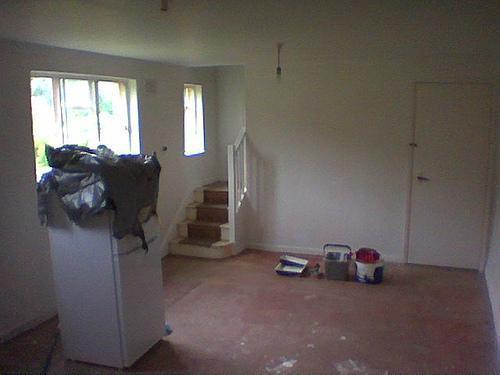How many dinosaurs are in the picture?
Give a very brief answer. 0. How many elephants are on the stairs?
Give a very brief answer. 0. How many people are lying on the floor?
Give a very brief answer. 0. How many ceiling fans are there?
Give a very brief answer. 0. 